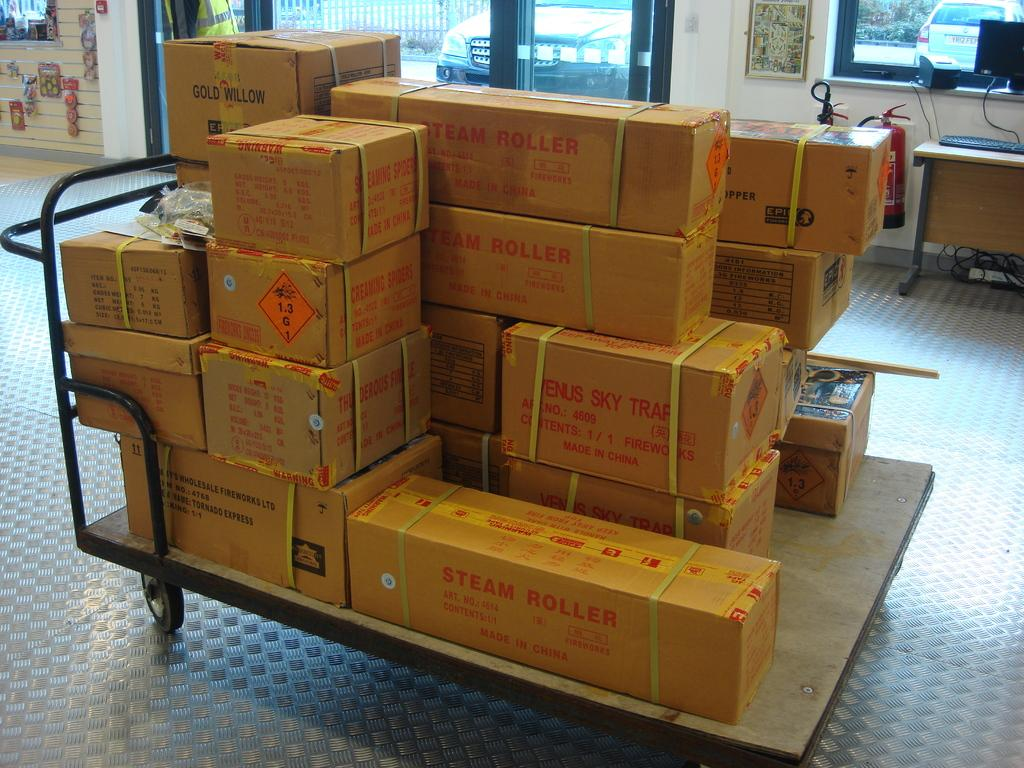<image>
Give a short and clear explanation of the subsequent image. A cart filled with boxes of packages from China. 